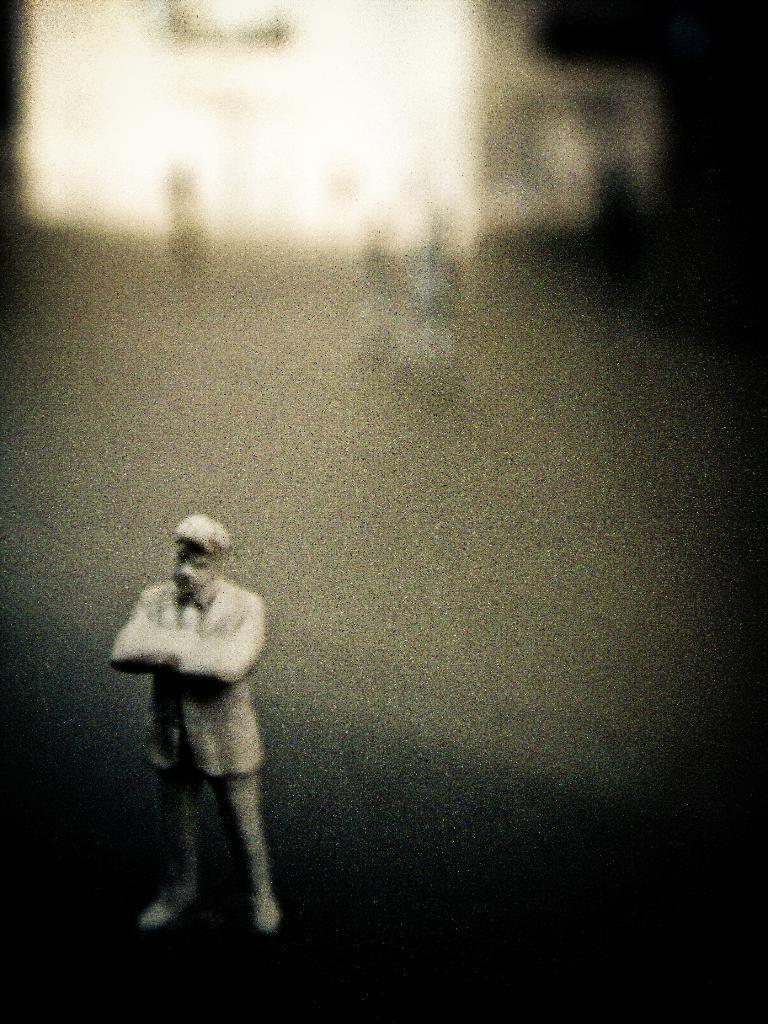Please provide a concise description of this image. In this picture there is a statue of a person standing and there are some other objects in the background. 